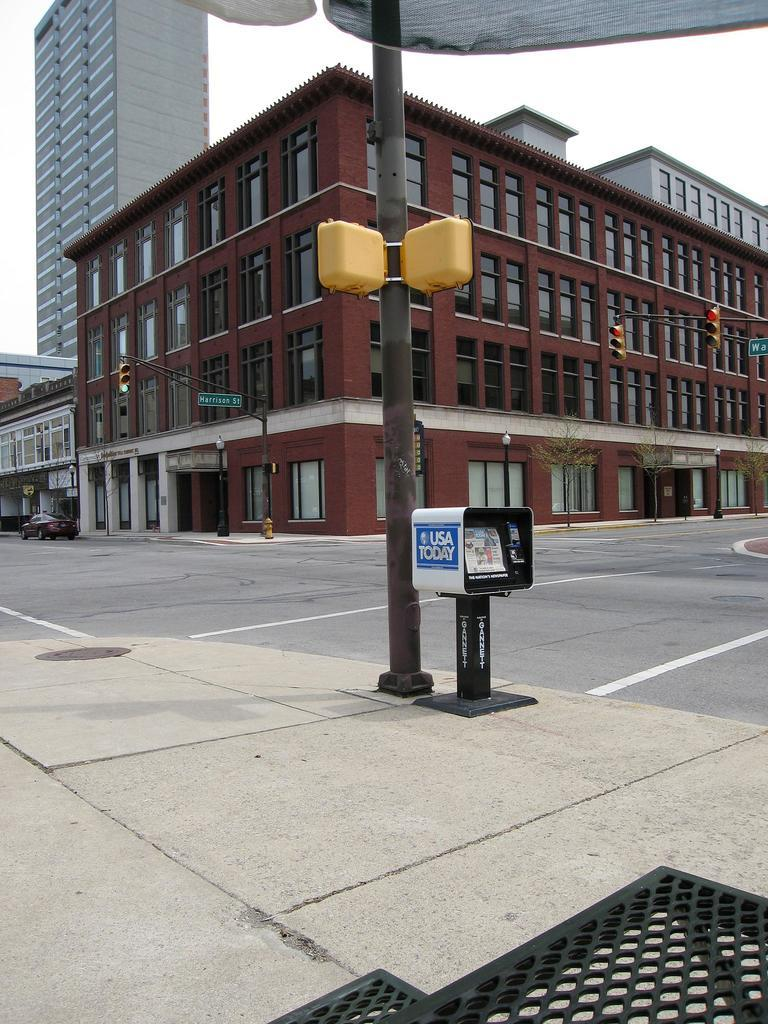What is on the road in the image? There is a vehicle on the road in the image. What objects can be seen alongside the road? There are poles and boards in the image. What can be seen illuminating the area in the image? There are lights in the image. What structures are visible in the background of the image? There are buildings and trees in the background of the image. What part of the natural environment is visible in the background of the image? The sky is visible in the background of the image. What color is the toe of the person walking in the image? There is no person walking in the image, and therefore no toe to describe. What type of lipstick is the person wearing in the image? There is no person wearing lipstick in the image. 